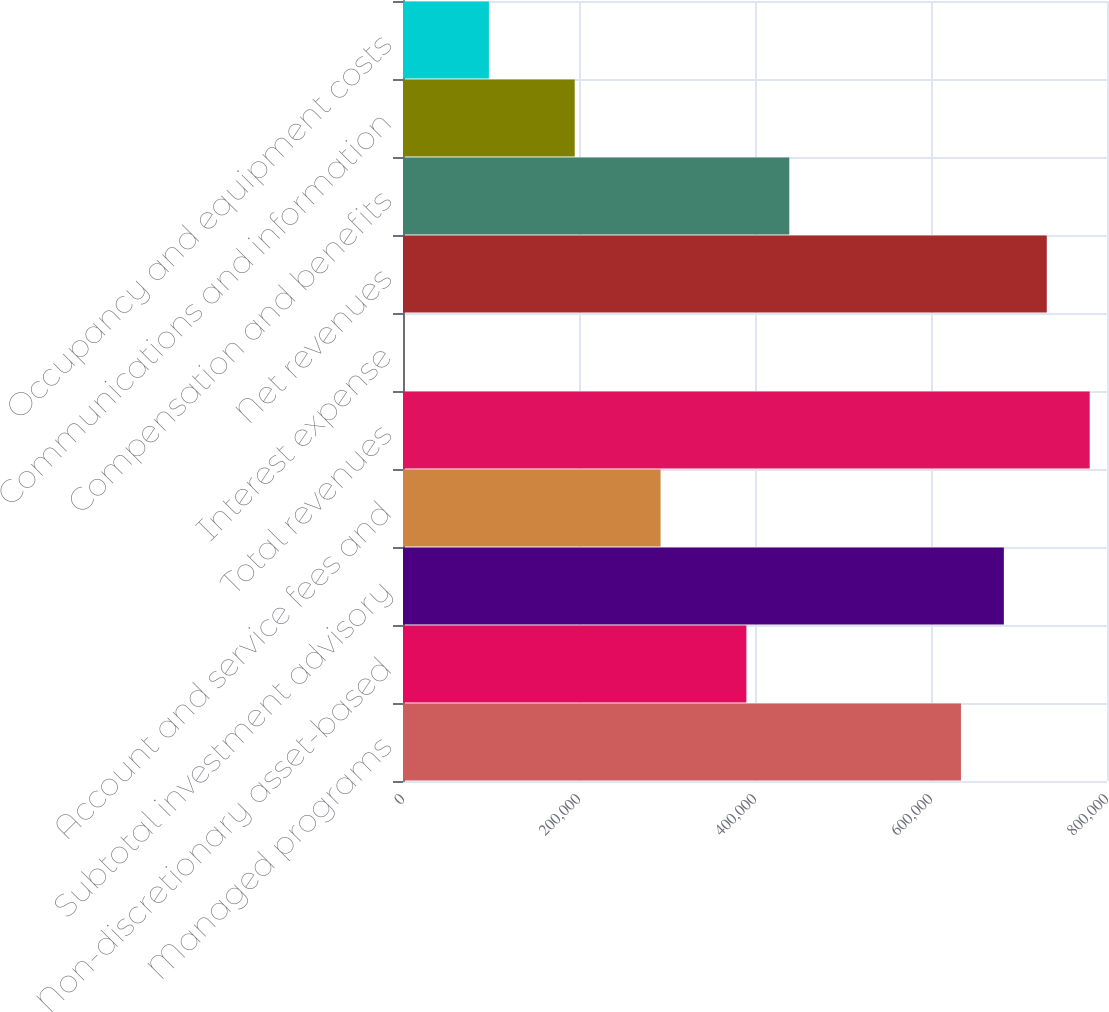Convert chart. <chart><loc_0><loc_0><loc_500><loc_500><bar_chart><fcel>Managed programs<fcel>Non-discretionary asset-based<fcel>Subtotal investment advisory<fcel>Account and service fees and<fcel>Total revenues<fcel>Interest expense<fcel>Net revenues<fcel>Compensation and benefits<fcel>Communications and information<fcel>Occupancy and equipment costs<nl><fcel>634032<fcel>390203<fcel>682798<fcel>292672<fcel>780330<fcel>77<fcel>731564<fcel>438969<fcel>195140<fcel>97608.6<nl></chart> 